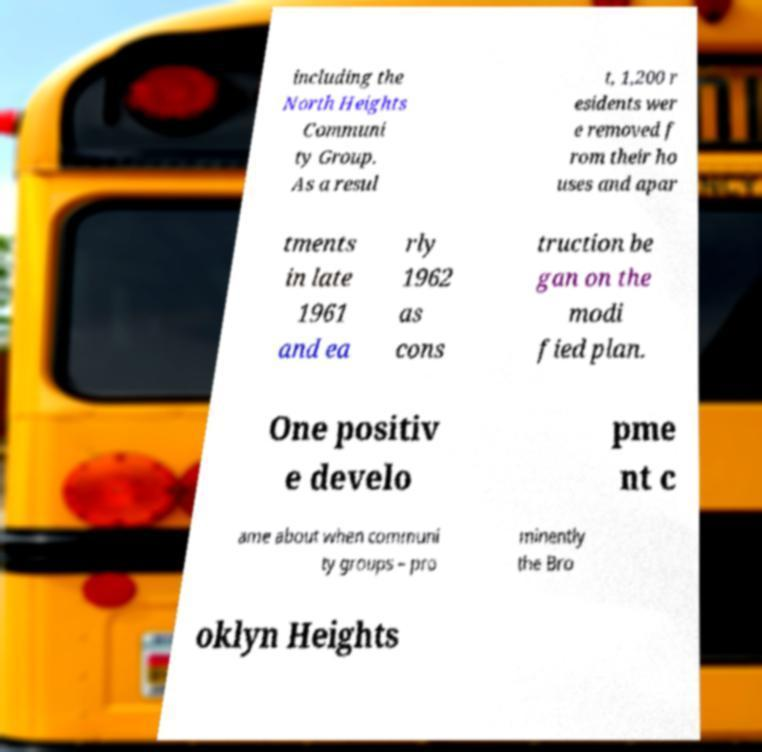Can you accurately transcribe the text from the provided image for me? including the North Heights Communi ty Group. As a resul t, 1,200 r esidents wer e removed f rom their ho uses and apar tments in late 1961 and ea rly 1962 as cons truction be gan on the modi fied plan. One positiv e develo pme nt c ame about when communi ty groups – pro minently the Bro oklyn Heights 